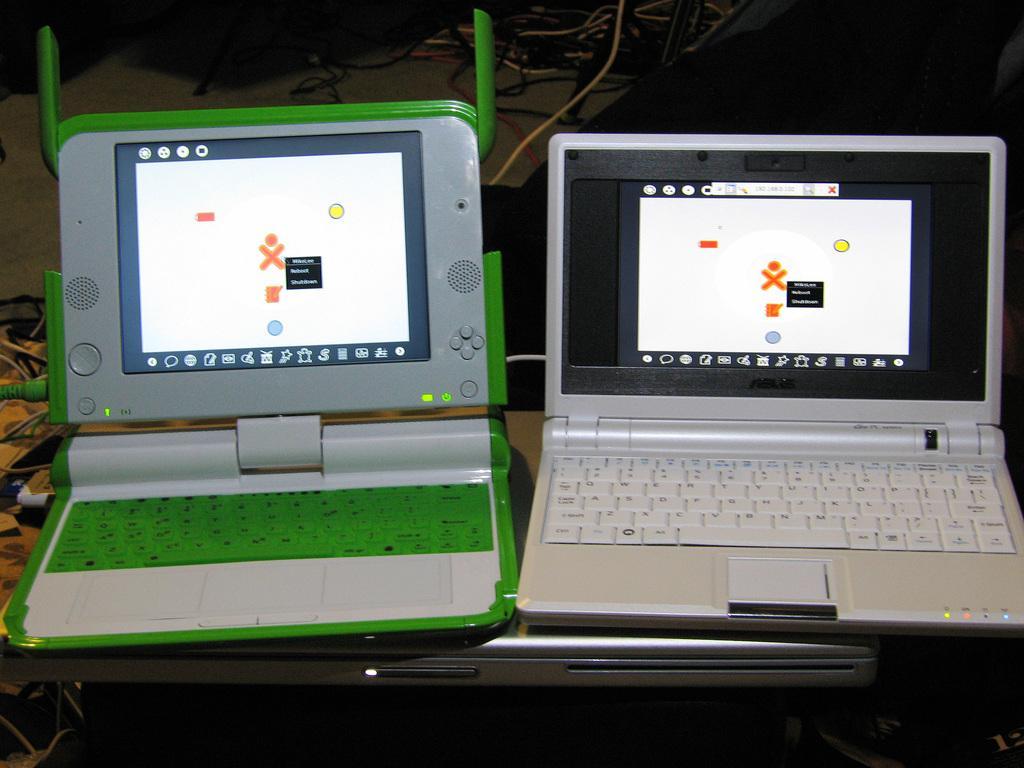Can you describe this image briefly? In the picture we can see a desk with a laptop and on it we can see two laptops which are opened, one is in green color keys and green color borders and one is with a gray color and white color keys and behind it we can see some wires with connectors on the floor. 